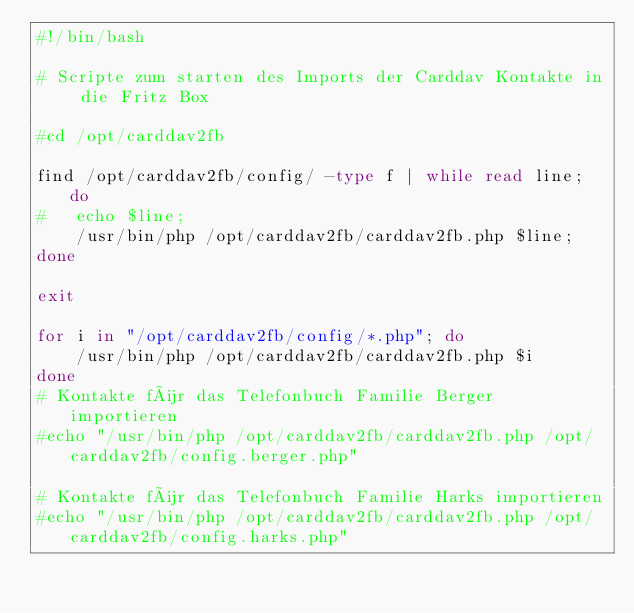Convert code to text. <code><loc_0><loc_0><loc_500><loc_500><_Bash_>#!/bin/bash

# Scripte zum starten des Imports der Carddav Kontakte in die Fritz Box

#cd /opt/carddav2fb

find /opt/carddav2fb/config/ -type f | while read line; do 
#	echo $line; 
	/usr/bin/php /opt/carddav2fb/carddav2fb.php $line;
done

exit

for i in "/opt/carddav2fb/config/*.php"; do
	/usr/bin/php /opt/carddav2fb/carddav2fb.php $i
done
# Kontakte für das Telefonbuch Familie Berger importieren
#echo "/usr/bin/php /opt/carddav2fb/carddav2fb.php /opt/carddav2fb/config.berger.php"

# Kontakte für das Telefonbuch Familie Harks importieren
#echo "/usr/bin/php /opt/carddav2fb/carddav2fb.php /opt/carddav2fb/config.harks.php"
</code> 